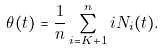<formula> <loc_0><loc_0><loc_500><loc_500>\theta ( t ) = \frac { 1 } { n } \sum _ { i = K + 1 } ^ { n } i N _ { i } ( t ) .</formula> 